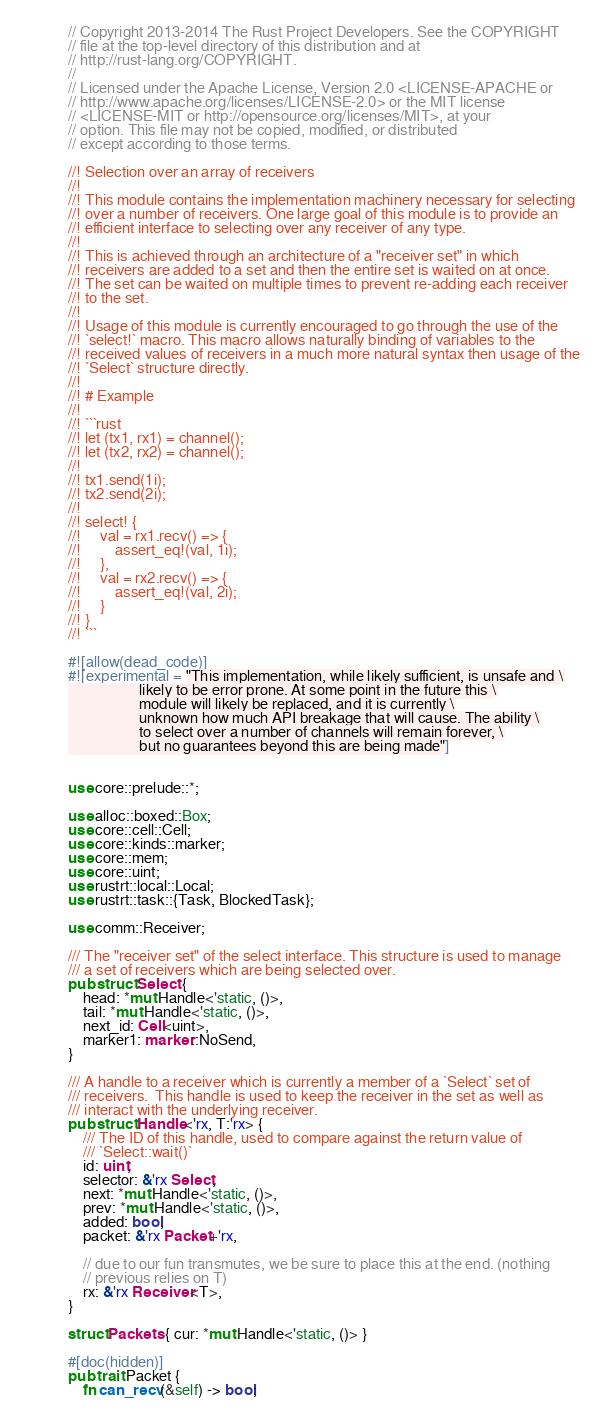<code> <loc_0><loc_0><loc_500><loc_500><_Rust_>// Copyright 2013-2014 The Rust Project Developers. See the COPYRIGHT
// file at the top-level directory of this distribution and at
// http://rust-lang.org/COPYRIGHT.
//
// Licensed under the Apache License, Version 2.0 <LICENSE-APACHE or
// http://www.apache.org/licenses/LICENSE-2.0> or the MIT license
// <LICENSE-MIT or http://opensource.org/licenses/MIT>, at your
// option. This file may not be copied, modified, or distributed
// except according to those terms.

//! Selection over an array of receivers
//!
//! This module contains the implementation machinery necessary for selecting
//! over a number of receivers. One large goal of this module is to provide an
//! efficient interface to selecting over any receiver of any type.
//!
//! This is achieved through an architecture of a "receiver set" in which
//! receivers are added to a set and then the entire set is waited on at once.
//! The set can be waited on multiple times to prevent re-adding each receiver
//! to the set.
//!
//! Usage of this module is currently encouraged to go through the use of the
//! `select!` macro. This macro allows naturally binding of variables to the
//! received values of receivers in a much more natural syntax then usage of the
//! `Select` structure directly.
//!
//! # Example
//!
//! ```rust
//! let (tx1, rx1) = channel();
//! let (tx2, rx2) = channel();
//!
//! tx1.send(1i);
//! tx2.send(2i);
//!
//! select! {
//!     val = rx1.recv() => {
//!         assert_eq!(val, 1i);
//!     },
//!     val = rx2.recv() => {
//!         assert_eq!(val, 2i);
//!     }
//! }
//! ```

#![allow(dead_code)]
#![experimental = "This implementation, while likely sufficient, is unsafe and \
                   likely to be error prone. At some point in the future this \
                   module will likely be replaced, and it is currently \
                   unknown how much API breakage that will cause. The ability \
                   to select over a number of channels will remain forever, \
                   but no guarantees beyond this are being made"]


use core::prelude::*;

use alloc::boxed::Box;
use core::cell::Cell;
use core::kinds::marker;
use core::mem;
use core::uint;
use rustrt::local::Local;
use rustrt::task::{Task, BlockedTask};

use comm::Receiver;

/// The "receiver set" of the select interface. This structure is used to manage
/// a set of receivers which are being selected over.
pub struct Select {
    head: *mut Handle<'static, ()>,
    tail: *mut Handle<'static, ()>,
    next_id: Cell<uint>,
    marker1: marker::NoSend,
}

/// A handle to a receiver which is currently a member of a `Select` set of
/// receivers.  This handle is used to keep the receiver in the set as well as
/// interact with the underlying receiver.
pub struct Handle<'rx, T:'rx> {
    /// The ID of this handle, used to compare against the return value of
    /// `Select::wait()`
    id: uint,
    selector: &'rx Select,
    next: *mut Handle<'static, ()>,
    prev: *mut Handle<'static, ()>,
    added: bool,
    packet: &'rx Packet+'rx,

    // due to our fun transmutes, we be sure to place this at the end. (nothing
    // previous relies on T)
    rx: &'rx Receiver<T>,
}

struct Packets { cur: *mut Handle<'static, ()> }

#[doc(hidden)]
pub trait Packet {
    fn can_recv(&self) -> bool;</code> 